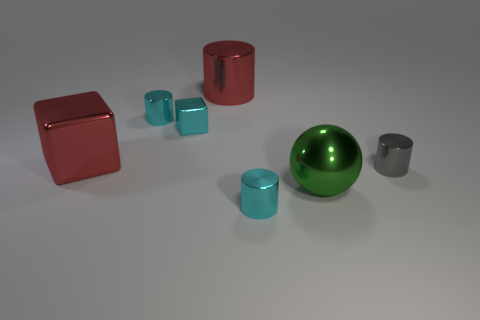How many things are small cyan cylinders or metallic objects that are on the left side of the tiny gray metallic thing?
Make the answer very short. 6. There is a thing that is both in front of the tiny cyan shiny block and behind the small gray metal cylinder; how big is it?
Offer a terse response. Large. Are there more tiny cyan things in front of the gray thing than large objects that are to the left of the red block?
Offer a terse response. Yes. There is a gray thing; is it the same shape as the tiny cyan object in front of the tiny gray thing?
Your answer should be compact. Yes. What number of other objects are the same shape as the green metallic thing?
Provide a succinct answer. 0. There is a tiny thing that is on the right side of the small cyan metallic block and to the left of the big green sphere; what is its color?
Your response must be concise. Cyan. The shiny sphere has what color?
Offer a very short reply. Green. What shape is the big green thing that is the same material as the big red cylinder?
Your answer should be very brief. Sphere. What color is the sphere that is the same size as the red cylinder?
Keep it short and to the point. Green. There is a metallic object that is right of the green sphere; is it the same size as the tiny cyan metallic block?
Offer a terse response. Yes. 